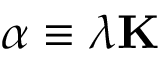<formula> <loc_0><loc_0><loc_500><loc_500>\alpha \equiv \lambda K</formula> 